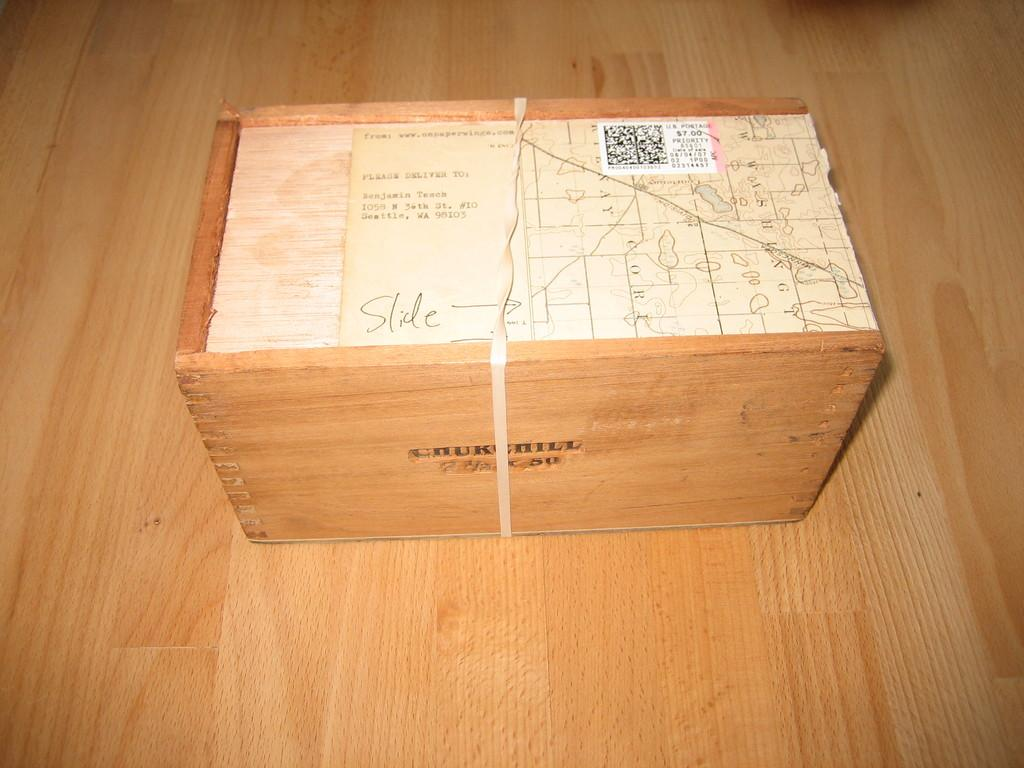<image>
Render a clear and concise summary of the photo. A wooden box that says slide on the top. 